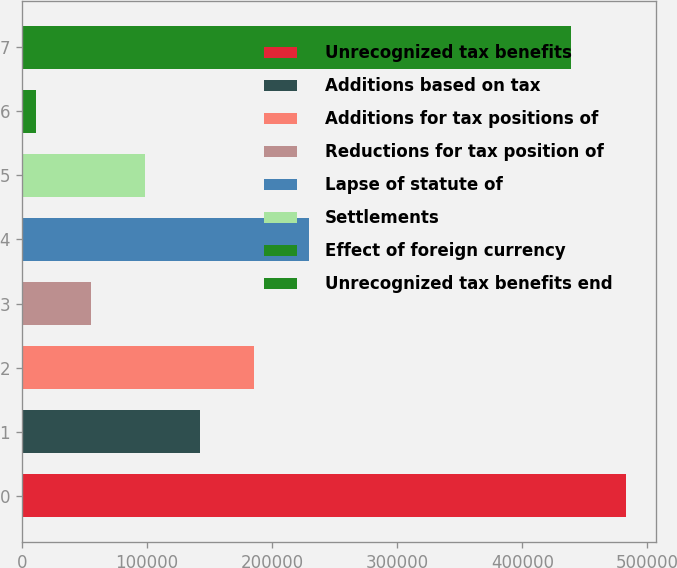Convert chart. <chart><loc_0><loc_0><loc_500><loc_500><bar_chart><fcel>Unrecognized tax benefits<fcel>Additions based on tax<fcel>Additions for tax positions of<fcel>Reductions for tax position of<fcel>Lapse of statute of<fcel>Settlements<fcel>Effect of foreign currency<fcel>Unrecognized tax benefits end<nl><fcel>482855<fcel>142190<fcel>185719<fcel>55131.9<fcel>229248<fcel>98660.8<fcel>11603<fcel>439326<nl></chart> 